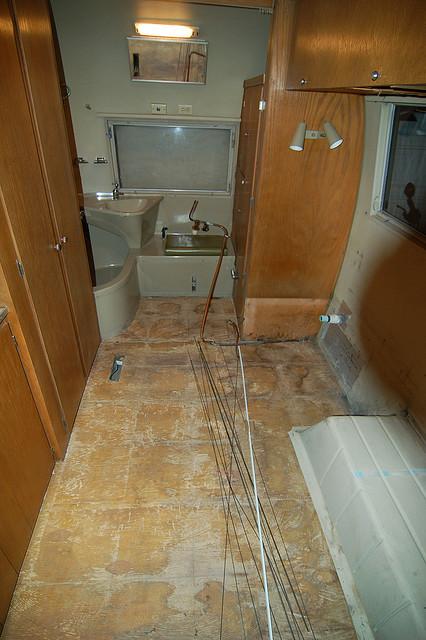Is this room tidy?
Give a very brief answer. No. Does this room need remodeled?
Write a very short answer. Yes. What room is this?
Give a very brief answer. Bathroom. 